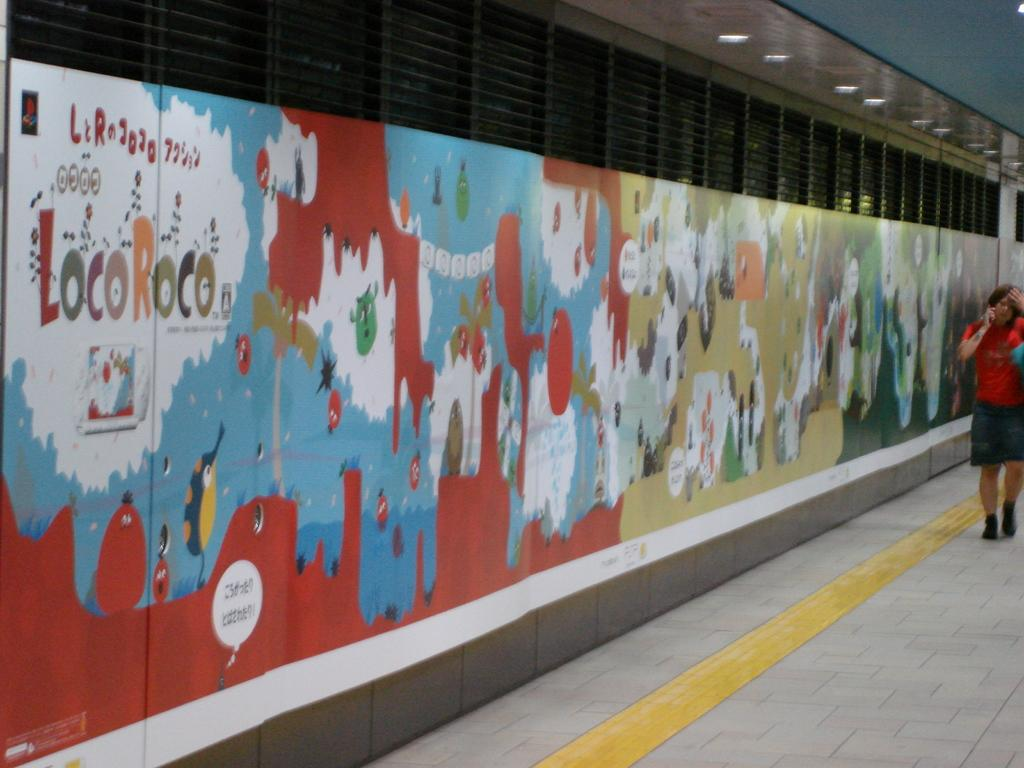What can be seen on the wall in the image? The wall in the image contains designs and text. Can you describe the person on the right side of the image? The person is wearing clothes. What is visible in the top right of the image? There are lights in the top right of the image. Can you tell me how many nails are used to hold the seashore in place in the image? There is no seashore present in the image, and therefore no nails are used to hold it in place. Is there a guide visible in the image to help the person on the right side? There is no guide visible in the image. 